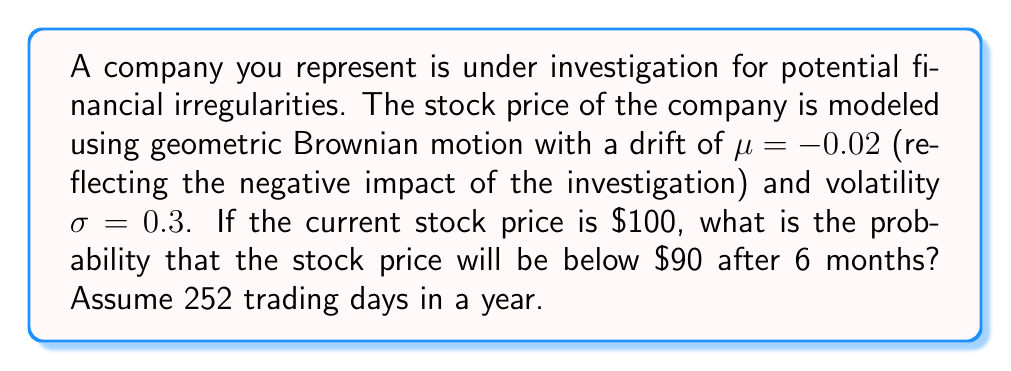Could you help me with this problem? To solve this problem, we'll use the properties of geometric Brownian motion and the log-normal distribution of stock prices.

Step 1: Calculate the time in years
$t = \frac{6 \text{ months}}{12 \text{ months/year}} = 0.5 \text{ years}$

Step 2: Calculate the mean of the log-normal distribution
$\mu_{\ln} = \ln(S_0) + (\mu - \frac{\sigma^2}{2})t$
$\mu_{\ln} = \ln(100) + (-0.02 - \frac{0.3^2}{2})(0.5)$
$\mu_{\ln} = 4.6052 - 0.03375 = 4.57145$

Step 3: Calculate the standard deviation of the log-normal distribution
$\sigma_{\ln} = \sigma \sqrt{t}$
$\sigma_{\ln} = 0.3 \sqrt{0.5} = 0.21213$

Step 4: Calculate the z-score for the target price ($90)
$z = \frac{\ln(90) - \mu_{\ln}}{\sigma_{\ln}}$
$z = \frac{4.49981 - 4.57145}{0.21213} = -0.33769$

Step 5: Use the standard normal distribution function $\Phi(z)$ to find the probability
The probability is $\Phi(-0.33769)$, which can be calculated using a standard normal table or a calculator.

$\Phi(-0.33769) \approx 0.3678$

Therefore, the probability that the stock price will be below $90 after 6 months is approximately 0.3678 or 36.78%.
Answer: 0.3678 (36.78%) 